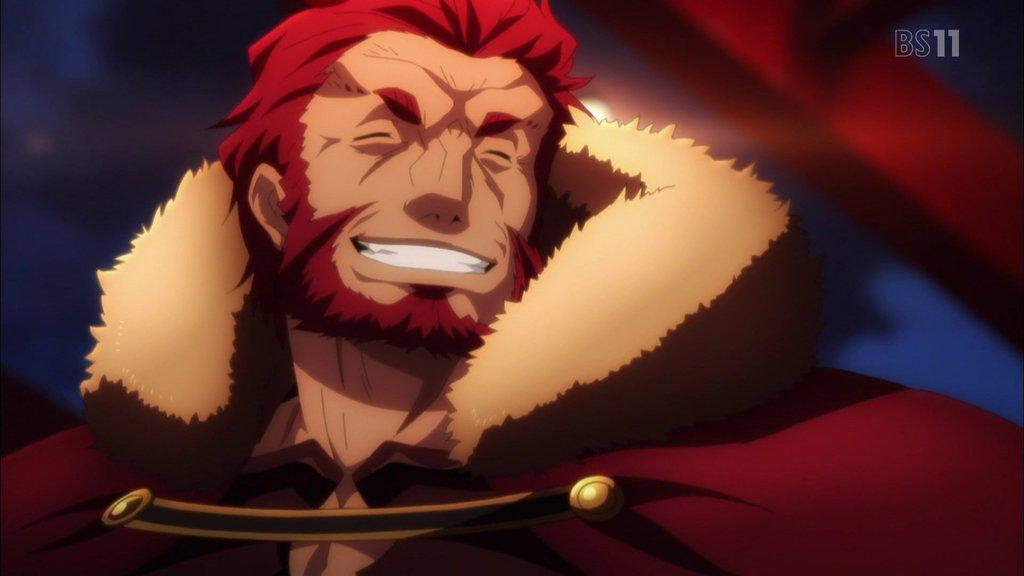What type of image is being described? The image is animated. Can you describe any additional features of the image? There is a watermark on the top right of the image. How would you characterize the background of the image? The background of the image is blurred. What is the cause of the blurred background in the image? The cause of the blurred background in the image is not mentioned in the provided facts. What type of wax can be seen being applied to the rifle in the image? There is no rifle or wax present in the image. 